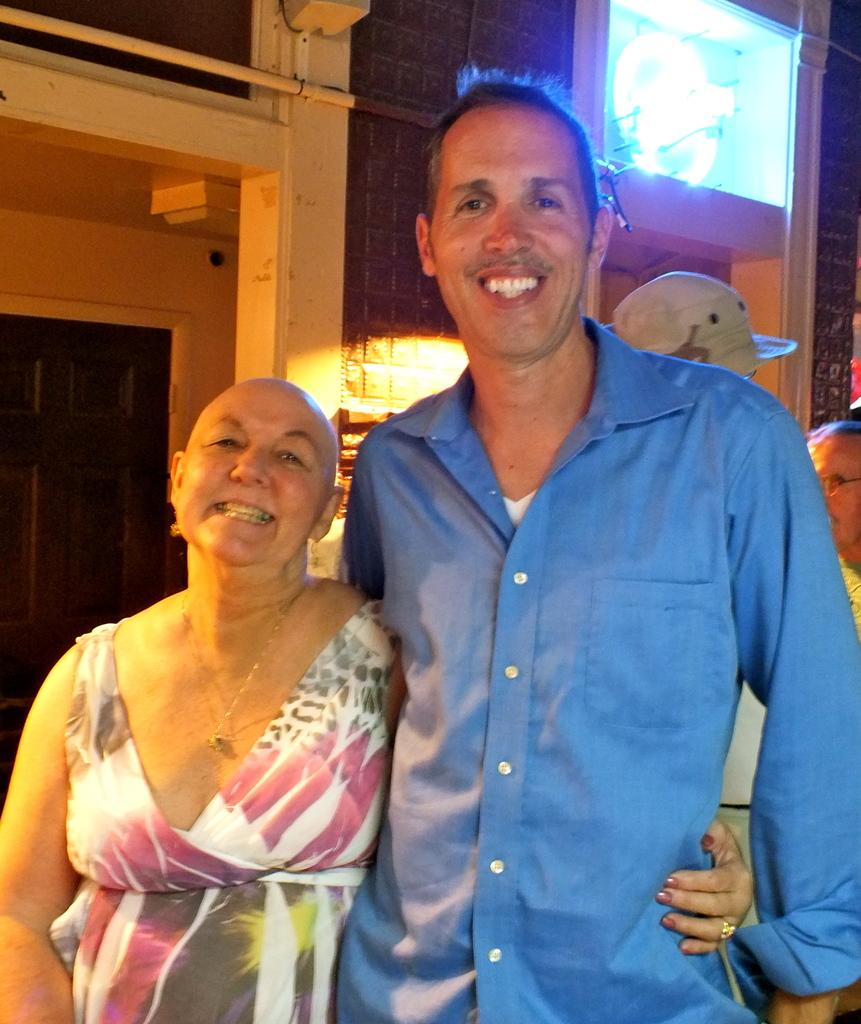How many people are smiling in the image? There are two persons standing and smiling in the image. Can you describe the other people in the image? There are other people standing in the image. What can be seen in the background of the image? There is a door visible in the background of the image, along with some objects. What riddle is being solved by the people in the image? There is no indication in the image that the people are solving a riddle. --- Facts: 1. There is a car in the image. 2. The car is parked on the street. 3. There are trees on both sides of the street. 4. The sky is visible in the image. Absurd Topics: dance, ocean, birdhouse Conversation: What is the main subject of the image? The main subject of the image is a car. Where is the car located in the image? The car is parked on the street. What can be seen on both sides of the street? There are trees on both sides of the street. What is visible in the background of the image? The sky is visible in the image. Reasoning: Let's think step by step in order to produce the conversation. We start by identifying the main subject in the image, which is the car. Then, we describe the location of the car, mentioning that it is parked on the street. Next, we expand the conversation to include the trees on both sides of the street and the sky visible in the background. Absurd Question/Answer: Where is the birdhouse located in the image? There is no birdhouse present in the image. What type of dance is being performed by the car in the image? Cars do not perform dances, so this question is not applicable to the image. 